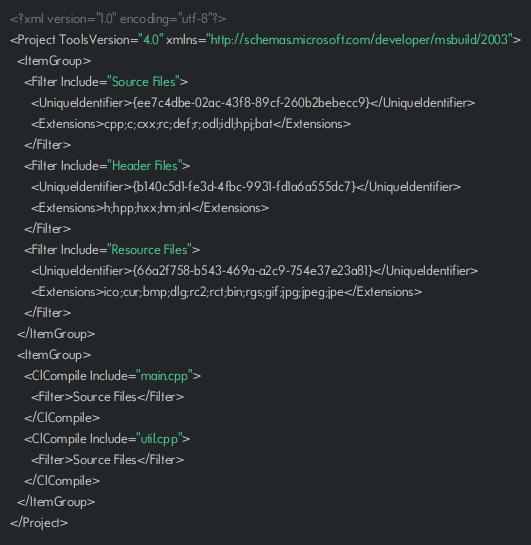<code> <loc_0><loc_0><loc_500><loc_500><_XML_><?xml version="1.0" encoding="utf-8"?>
<Project ToolsVersion="4.0" xmlns="http://schemas.microsoft.com/developer/msbuild/2003">
  <ItemGroup>
    <Filter Include="Source Files">
      <UniqueIdentifier>{ee7c4dbe-02ac-43f8-89cf-260b2bebecc9}</UniqueIdentifier>
      <Extensions>cpp;c;cxx;rc;def;r;odl;idl;hpj;bat</Extensions>
    </Filter>
    <Filter Include="Header Files">
      <UniqueIdentifier>{b140c5d1-fe3d-4fbc-9931-fd1a6a555dc7}</UniqueIdentifier>
      <Extensions>h;hpp;hxx;hm;inl</Extensions>
    </Filter>
    <Filter Include="Resource Files">
      <UniqueIdentifier>{66a2f758-b543-469a-a2c9-754e37e23a81}</UniqueIdentifier>
      <Extensions>ico;cur;bmp;dlg;rc2;rct;bin;rgs;gif;jpg;jpeg;jpe</Extensions>
    </Filter>
  </ItemGroup>
  <ItemGroup>
    <ClCompile Include="main.cpp">
      <Filter>Source Files</Filter>
    </ClCompile>
    <ClCompile Include="util.cpp">
      <Filter>Source Files</Filter>
    </ClCompile>
  </ItemGroup>
</Project></code> 